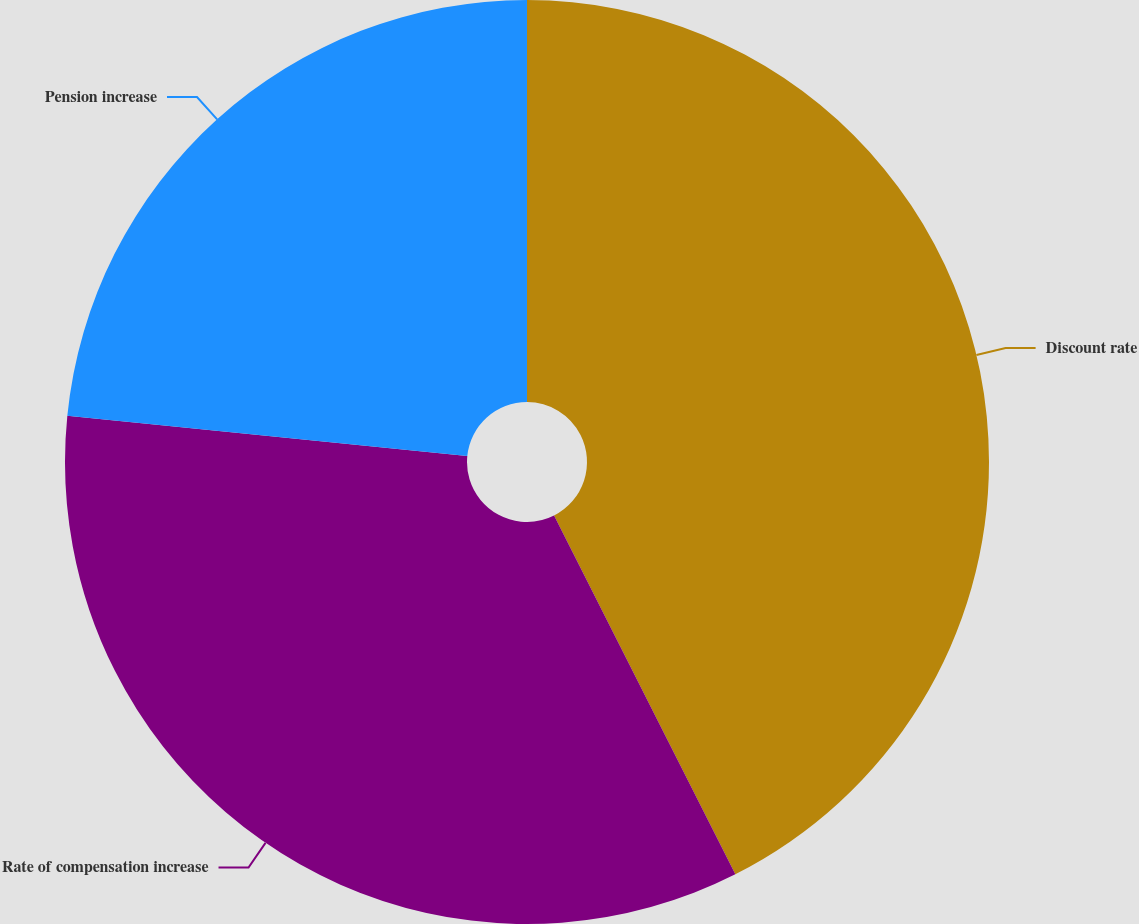<chart> <loc_0><loc_0><loc_500><loc_500><pie_chart><fcel>Discount rate<fcel>Rate of compensation increase<fcel>Pension increase<nl><fcel>42.55%<fcel>34.04%<fcel>23.4%<nl></chart> 